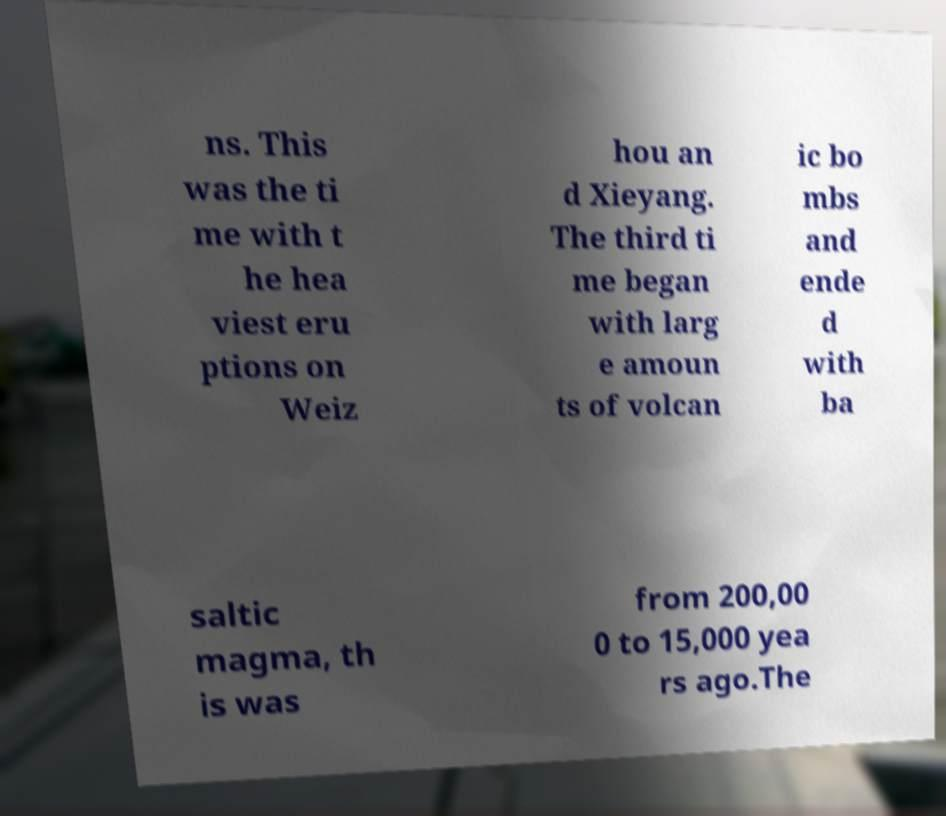Please read and relay the text visible in this image. What does it say? ns. This was the ti me with t he hea viest eru ptions on Weiz hou an d Xieyang. The third ti me began with larg e amoun ts of volcan ic bo mbs and ende d with ba saltic magma, th is was from 200,00 0 to 15,000 yea rs ago.The 